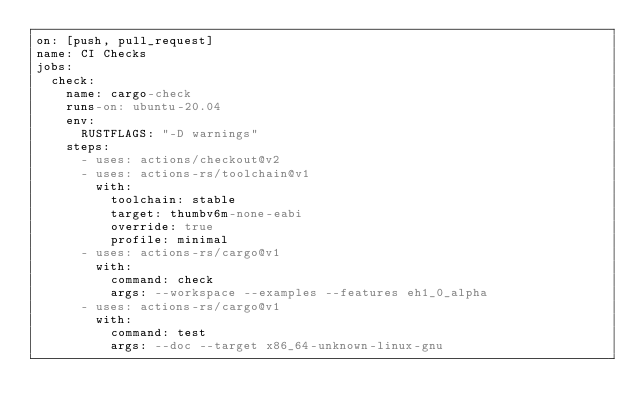<code> <loc_0><loc_0><loc_500><loc_500><_YAML_>on: [push, pull_request]
name: CI Checks
jobs:
  check:
    name: cargo-check
    runs-on: ubuntu-20.04
    env:
      RUSTFLAGS: "-D warnings"
    steps:
      - uses: actions/checkout@v2
      - uses: actions-rs/toolchain@v1
        with:
          toolchain: stable
          target: thumbv6m-none-eabi
          override: true
          profile: minimal
      - uses: actions-rs/cargo@v1
        with:
          command: check
          args: --workspace --examples --features eh1_0_alpha
      - uses: actions-rs/cargo@v1
        with:
          command: test
          args: --doc --target x86_64-unknown-linux-gnu</code> 